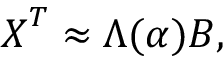Convert formula to latex. <formula><loc_0><loc_0><loc_500><loc_500>X ^ { T } \approx \Lambda ( \alpha ) B ,</formula> 